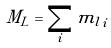<formula> <loc_0><loc_0><loc_500><loc_500>M _ { L } = \sum _ { i } { m _ { l } } _ { i }</formula> 